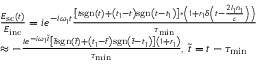Convert formula to latex. <formula><loc_0><loc_0><loc_500><loc_500>\begin{array} { r l } & { \frac { E _ { s c } ( t ) } { E _ { i n c } } = i e ^ { - i \omega _ { 1 } t } \frac { \left [ t s g n ( t ) + \left ( t _ { 1 } - t \right ) s g n \left ( t - t _ { 1 } \right ) \right ] * \left ( 1 + r _ { 1 } \delta \left ( t - \frac { 2 l _ { 1 } n _ { 1 } } { c } \right ) \right ) } { \tau _ { \min } } } \\ & { \approx - \frac { i e ^ { - i \omega _ { 1 } \tilde { t } } \left [ \tilde { t } s g n ( \tilde { t } ) + \left ( t _ { 1 } - \tilde { t } \right ) s g n \left ( \tilde { t } - t _ { 1 } \right ) \right ] \left ( 1 + r _ { 1 } \right ) } { \tau _ { \min } } , \, \tilde { t } = t - \tau _ { \min } } \end{array}</formula> 